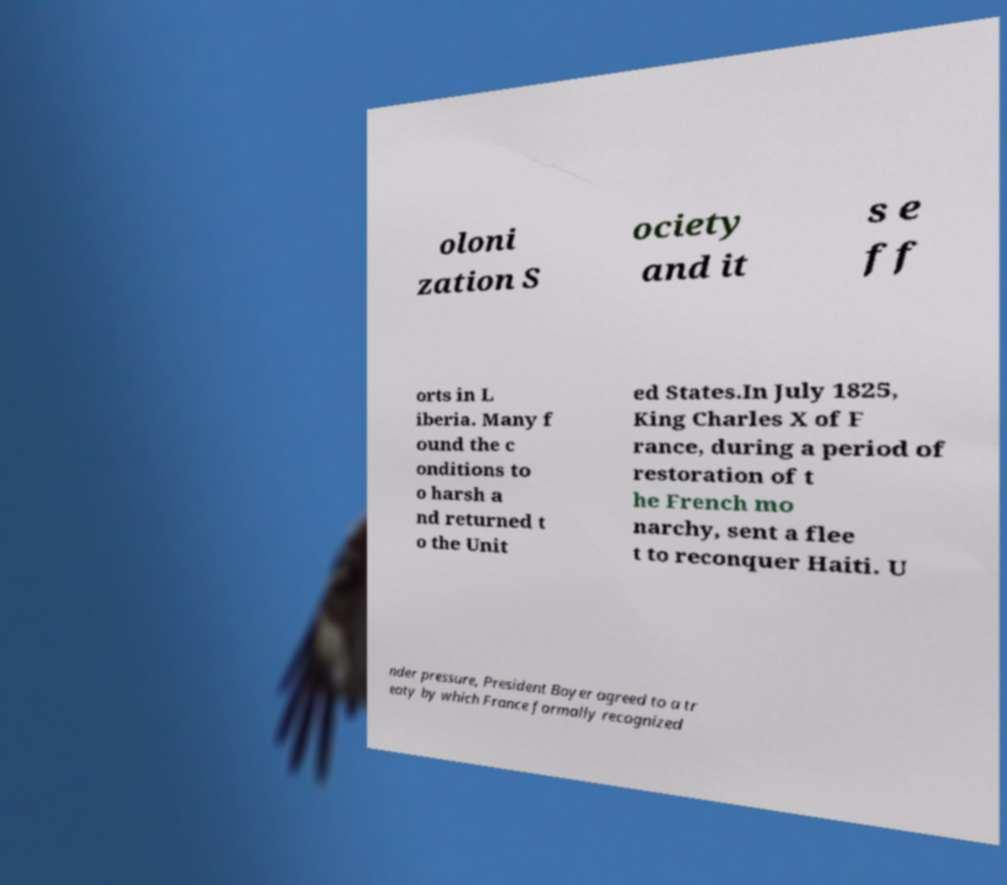Please identify and transcribe the text found in this image. oloni zation S ociety and it s e ff orts in L iberia. Many f ound the c onditions to o harsh a nd returned t o the Unit ed States.In July 1825, King Charles X of F rance, during a period of restoration of t he French mo narchy, sent a flee t to reconquer Haiti. U nder pressure, President Boyer agreed to a tr eaty by which France formally recognized 